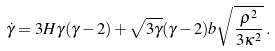<formula> <loc_0><loc_0><loc_500><loc_500>\dot { \gamma } = 3 H \gamma ( \gamma - 2 ) + \sqrt { 3 \gamma } ( \gamma - 2 ) b \sqrt { \frac { \rho ^ { 2 } } { 3 \kappa ^ { 2 } } } \, .</formula> 